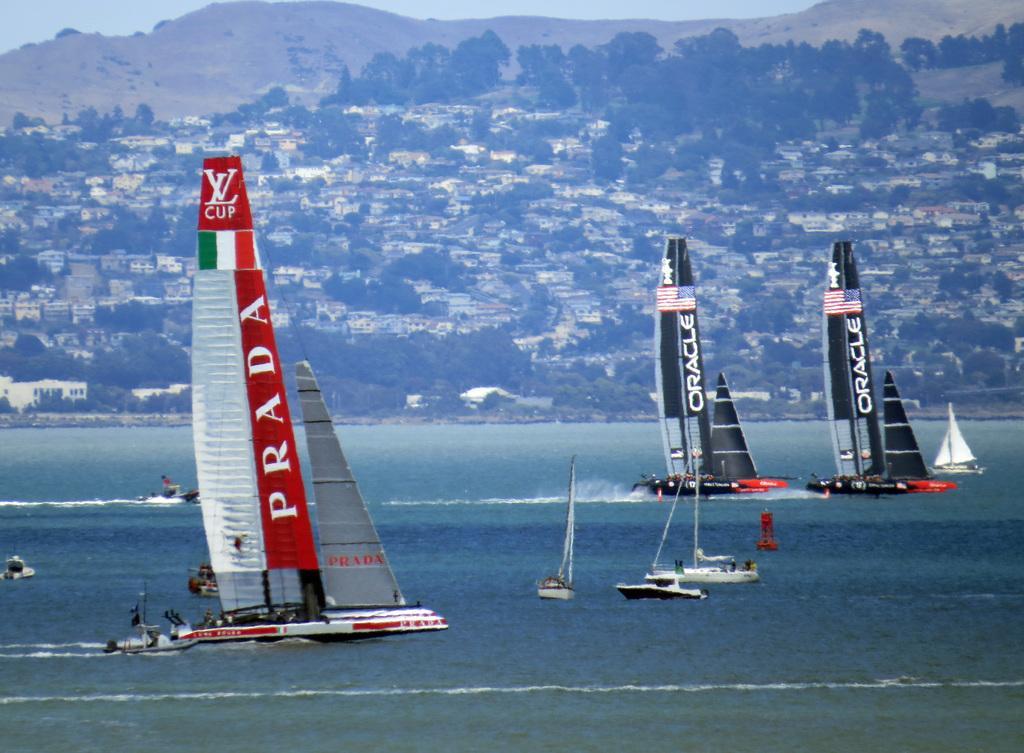Can you describe this image briefly? In this image, we can see few boats are sailing on the water. Background we can see so many trees, houses, buildings, hills and sky. 